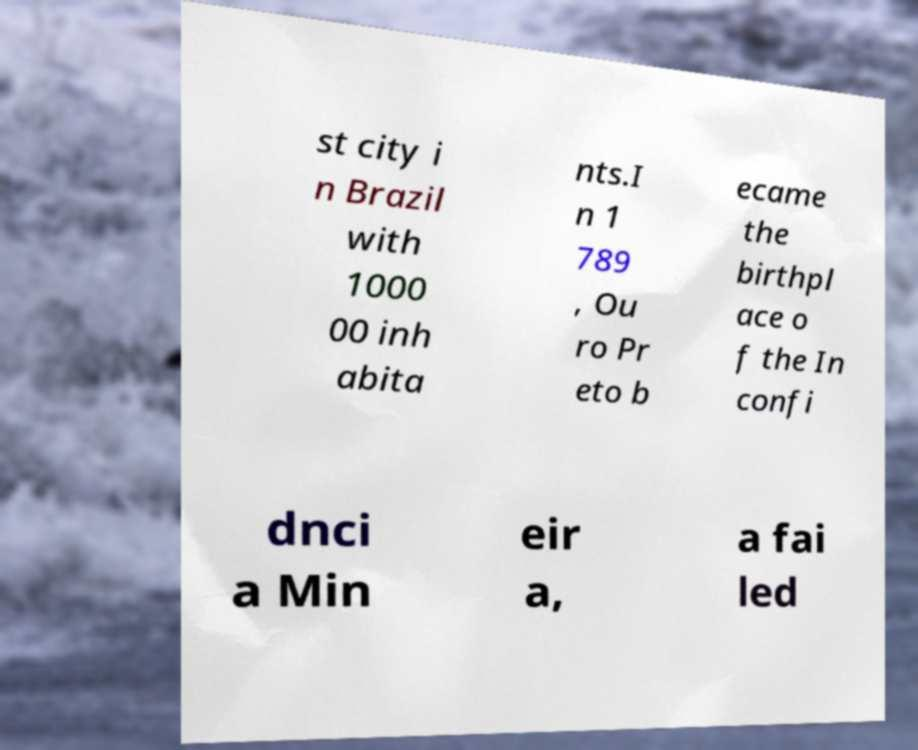I need the written content from this picture converted into text. Can you do that? st city i n Brazil with 1000 00 inh abita nts.I n 1 789 , Ou ro Pr eto b ecame the birthpl ace o f the In confi dnci a Min eir a, a fai led 